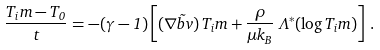Convert formula to latex. <formula><loc_0><loc_0><loc_500><loc_500>\frac { T _ { i } m - T _ { 0 } } { t } = - ( \gamma - 1 ) \left [ ( \nabla \vec { b } { v } ) \, T _ { i } m + \frac { \rho } { \mu k _ { B } } \, \Lambda ^ { \ast } ( \log T _ { i } m ) \right ] \, .</formula> 